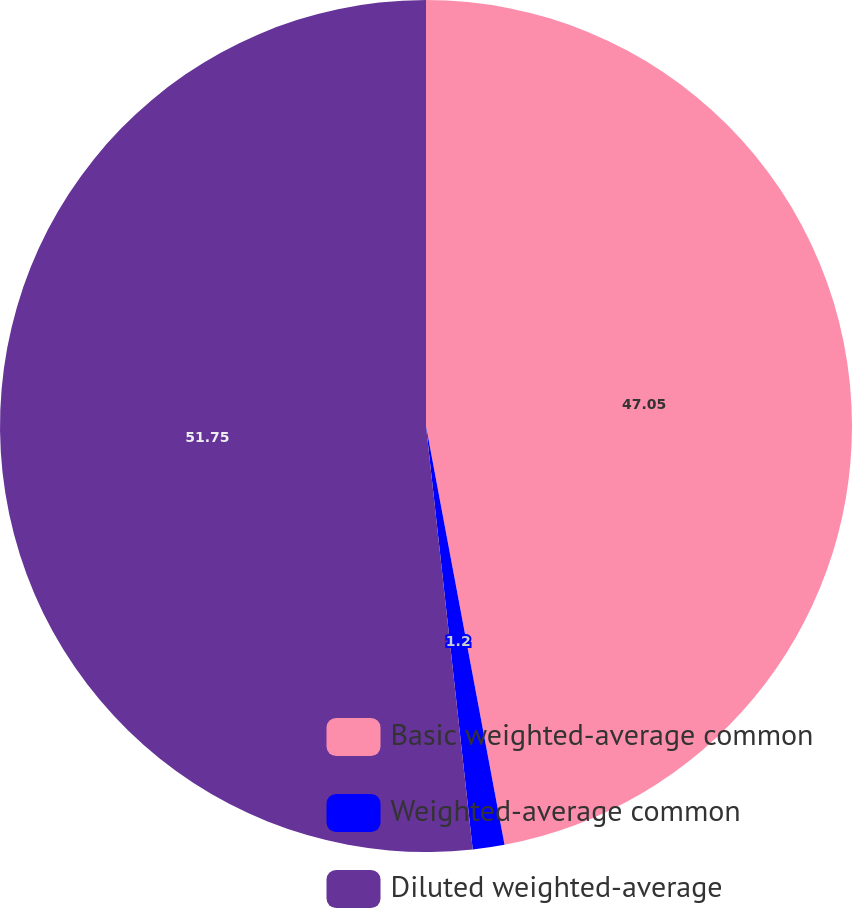Convert chart. <chart><loc_0><loc_0><loc_500><loc_500><pie_chart><fcel>Basic weighted-average common<fcel>Weighted-average common<fcel>Diluted weighted-average<nl><fcel>47.05%<fcel>1.2%<fcel>51.75%<nl></chart> 